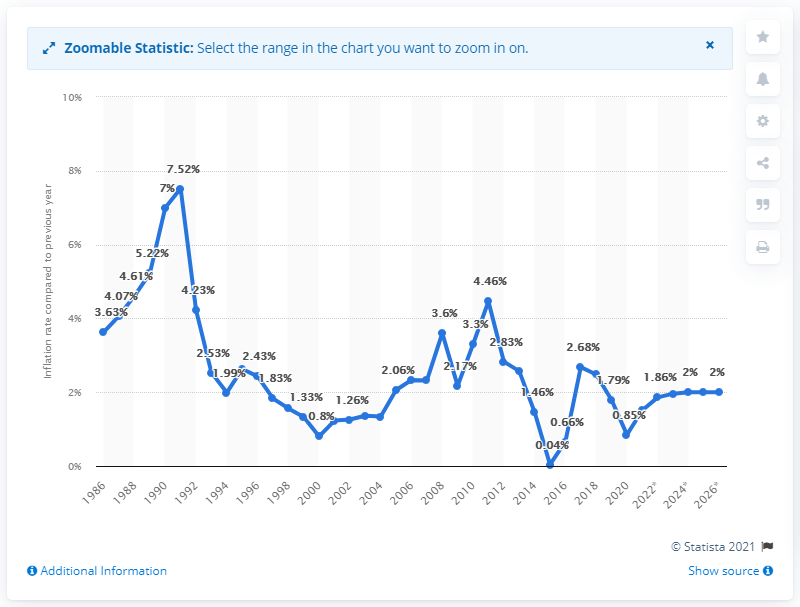Highlight a few significant elements in this photo. In 2020, the inflation rate in the United Kingdom was 0.85%. 